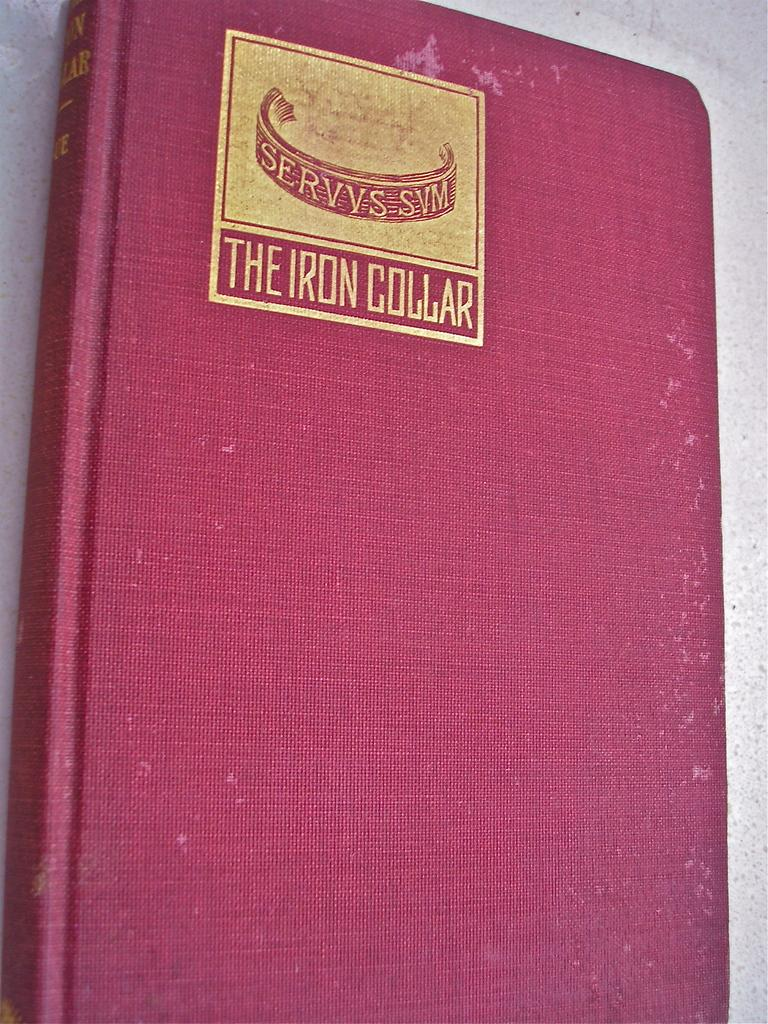<image>
Describe the image concisely. A red canvas covered book titled The Iron Collar. 